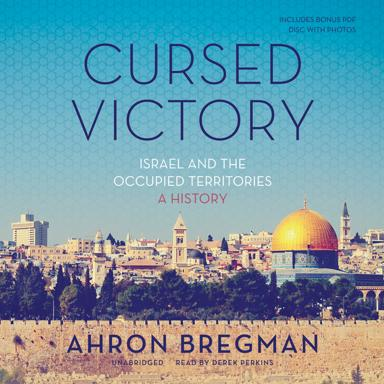What is the bonus item that comes with the book? The book comes with a bonus CD containing a collection of photographs, providing visual insights that complement the textual content. 